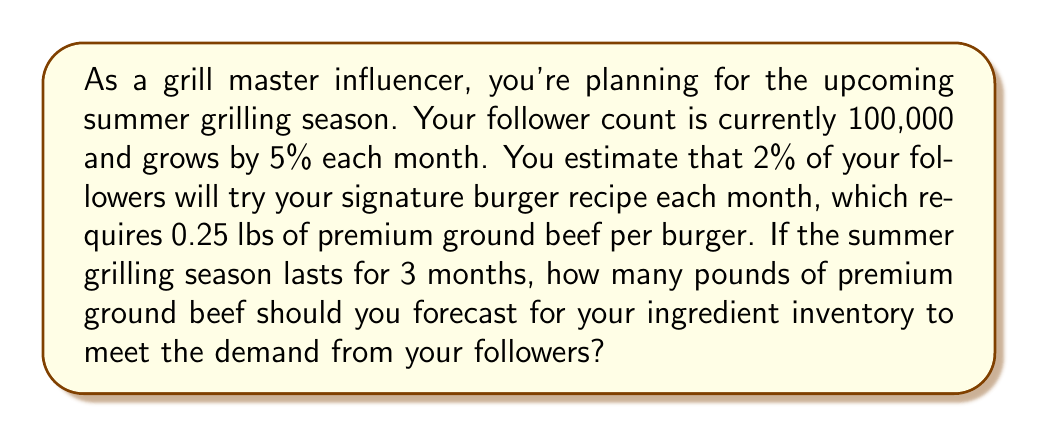Could you help me with this problem? Let's break this problem down step-by-step:

1. Calculate follower growth over 3 months:
   - Initial followers: 100,000
   - Monthly growth rate: 5% = 0.05
   - Followers after 1 month: $100,000 \times (1 + 0.05) = 105,000$
   - Followers after 2 months: $105,000 \times (1 + 0.05) = 110,250$
   - Followers after 3 months: $110,250 \times (1 + 0.05) = 115,762.5$

2. Calculate the number of followers trying the recipe each month:
   - Month 1: $105,000 \times 0.02 = 2,100$
   - Month 2: $110,250 \times 0.02 = 2,205$
   - Month 3: $115,762.5 \times 0.02 = 2,315.25$

3. Calculate the total number of followers trying the recipe:
   $2,100 + 2,205 + 2,315.25 = 6,620.25$

4. Calculate the amount of ground beef needed:
   Each burger requires 0.25 lbs of ground beef.
   Total ground beef needed: $6,620.25 \times 0.25 = 1,655.0625$ lbs

Therefore, you should forecast approximately 1,655.06 lbs of premium ground beef for your ingredient inventory.
Answer: 1,655.06 lbs 